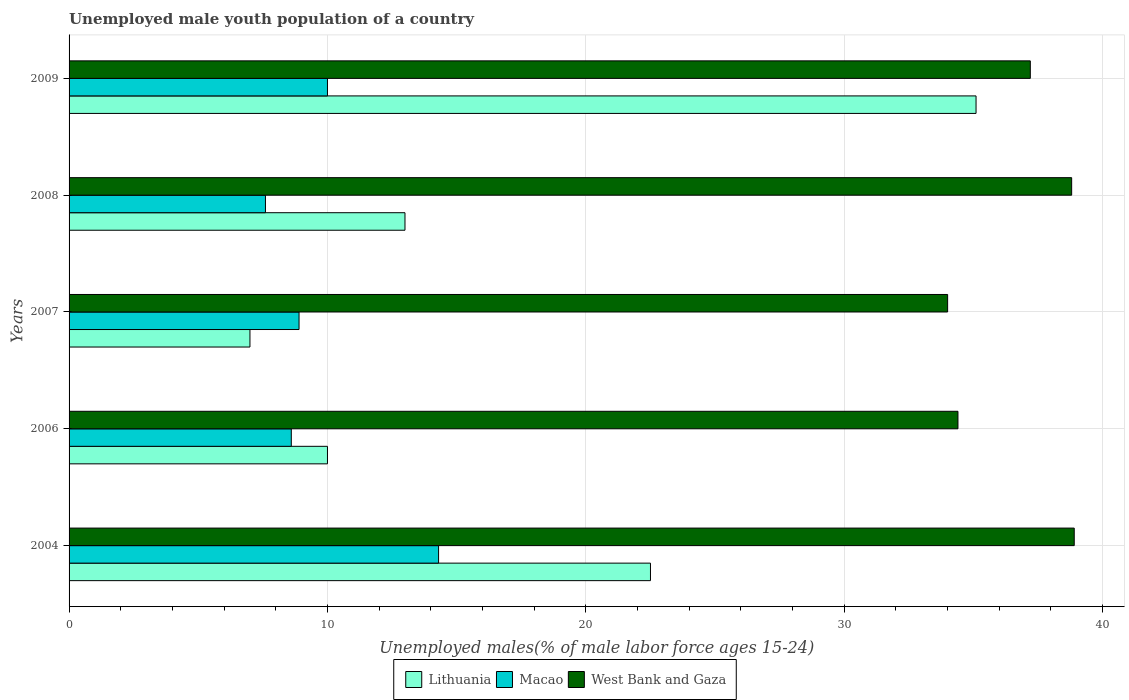What is the percentage of unemployed male youth population in Lithuania in 2009?
Your response must be concise. 35.1. Across all years, what is the maximum percentage of unemployed male youth population in Macao?
Your answer should be compact. 14.3. Across all years, what is the minimum percentage of unemployed male youth population in Lithuania?
Provide a succinct answer. 7. In which year was the percentage of unemployed male youth population in Macao maximum?
Your answer should be compact. 2004. What is the total percentage of unemployed male youth population in Lithuania in the graph?
Your response must be concise. 87.6. What is the difference between the percentage of unemployed male youth population in Macao in 2006 and that in 2008?
Your answer should be compact. 1. What is the difference between the percentage of unemployed male youth population in West Bank and Gaza in 2004 and the percentage of unemployed male youth population in Lithuania in 2006?
Your response must be concise. 28.9. What is the average percentage of unemployed male youth population in Macao per year?
Offer a very short reply. 9.88. In the year 2009, what is the difference between the percentage of unemployed male youth population in Lithuania and percentage of unemployed male youth population in West Bank and Gaza?
Offer a very short reply. -2.1. In how many years, is the percentage of unemployed male youth population in Macao greater than 26 %?
Your response must be concise. 0. What is the ratio of the percentage of unemployed male youth population in Macao in 2007 to that in 2009?
Your answer should be very brief. 0.89. Is the difference between the percentage of unemployed male youth population in Lithuania in 2006 and 2007 greater than the difference between the percentage of unemployed male youth population in West Bank and Gaza in 2006 and 2007?
Keep it short and to the point. Yes. What is the difference between the highest and the second highest percentage of unemployed male youth population in Macao?
Give a very brief answer. 4.3. What is the difference between the highest and the lowest percentage of unemployed male youth population in Lithuania?
Offer a very short reply. 28.1. What does the 2nd bar from the top in 2009 represents?
Your answer should be compact. Macao. What does the 3rd bar from the bottom in 2007 represents?
Offer a terse response. West Bank and Gaza. Is it the case that in every year, the sum of the percentage of unemployed male youth population in Macao and percentage of unemployed male youth population in West Bank and Gaza is greater than the percentage of unemployed male youth population in Lithuania?
Your answer should be very brief. Yes. What is the difference between two consecutive major ticks on the X-axis?
Give a very brief answer. 10. Are the values on the major ticks of X-axis written in scientific E-notation?
Make the answer very short. No. Does the graph contain grids?
Offer a very short reply. Yes. Where does the legend appear in the graph?
Your answer should be very brief. Bottom center. How many legend labels are there?
Provide a short and direct response. 3. How are the legend labels stacked?
Ensure brevity in your answer.  Horizontal. What is the title of the graph?
Your answer should be compact. Unemployed male youth population of a country. What is the label or title of the X-axis?
Provide a short and direct response. Unemployed males(% of male labor force ages 15-24). What is the label or title of the Y-axis?
Provide a short and direct response. Years. What is the Unemployed males(% of male labor force ages 15-24) of Lithuania in 2004?
Your answer should be compact. 22.5. What is the Unemployed males(% of male labor force ages 15-24) in Macao in 2004?
Offer a terse response. 14.3. What is the Unemployed males(% of male labor force ages 15-24) of West Bank and Gaza in 2004?
Make the answer very short. 38.9. What is the Unemployed males(% of male labor force ages 15-24) of Macao in 2006?
Your response must be concise. 8.6. What is the Unemployed males(% of male labor force ages 15-24) of West Bank and Gaza in 2006?
Keep it short and to the point. 34.4. What is the Unemployed males(% of male labor force ages 15-24) of Lithuania in 2007?
Keep it short and to the point. 7. What is the Unemployed males(% of male labor force ages 15-24) of Macao in 2007?
Provide a succinct answer. 8.9. What is the Unemployed males(% of male labor force ages 15-24) of West Bank and Gaza in 2007?
Offer a very short reply. 34. What is the Unemployed males(% of male labor force ages 15-24) in Macao in 2008?
Provide a short and direct response. 7.6. What is the Unemployed males(% of male labor force ages 15-24) of West Bank and Gaza in 2008?
Your response must be concise. 38.8. What is the Unemployed males(% of male labor force ages 15-24) of Lithuania in 2009?
Your answer should be very brief. 35.1. What is the Unemployed males(% of male labor force ages 15-24) in West Bank and Gaza in 2009?
Give a very brief answer. 37.2. Across all years, what is the maximum Unemployed males(% of male labor force ages 15-24) of Lithuania?
Provide a succinct answer. 35.1. Across all years, what is the maximum Unemployed males(% of male labor force ages 15-24) of Macao?
Your answer should be very brief. 14.3. Across all years, what is the maximum Unemployed males(% of male labor force ages 15-24) of West Bank and Gaza?
Provide a succinct answer. 38.9. Across all years, what is the minimum Unemployed males(% of male labor force ages 15-24) of Lithuania?
Keep it short and to the point. 7. Across all years, what is the minimum Unemployed males(% of male labor force ages 15-24) in Macao?
Provide a short and direct response. 7.6. What is the total Unemployed males(% of male labor force ages 15-24) in Lithuania in the graph?
Your answer should be very brief. 87.6. What is the total Unemployed males(% of male labor force ages 15-24) in Macao in the graph?
Your answer should be compact. 49.4. What is the total Unemployed males(% of male labor force ages 15-24) in West Bank and Gaza in the graph?
Your response must be concise. 183.3. What is the difference between the Unemployed males(% of male labor force ages 15-24) of West Bank and Gaza in 2004 and that in 2007?
Give a very brief answer. 4.9. What is the difference between the Unemployed males(% of male labor force ages 15-24) of Lithuania in 2004 and that in 2008?
Make the answer very short. 9.5. What is the difference between the Unemployed males(% of male labor force ages 15-24) of West Bank and Gaza in 2004 and that in 2008?
Give a very brief answer. 0.1. What is the difference between the Unemployed males(% of male labor force ages 15-24) in Macao in 2006 and that in 2007?
Offer a terse response. -0.3. What is the difference between the Unemployed males(% of male labor force ages 15-24) in West Bank and Gaza in 2006 and that in 2007?
Provide a short and direct response. 0.4. What is the difference between the Unemployed males(% of male labor force ages 15-24) in Lithuania in 2006 and that in 2008?
Give a very brief answer. -3. What is the difference between the Unemployed males(% of male labor force ages 15-24) of West Bank and Gaza in 2006 and that in 2008?
Make the answer very short. -4.4. What is the difference between the Unemployed males(% of male labor force ages 15-24) in Lithuania in 2006 and that in 2009?
Ensure brevity in your answer.  -25.1. What is the difference between the Unemployed males(% of male labor force ages 15-24) in Lithuania in 2007 and that in 2008?
Provide a succinct answer. -6. What is the difference between the Unemployed males(% of male labor force ages 15-24) of West Bank and Gaza in 2007 and that in 2008?
Keep it short and to the point. -4.8. What is the difference between the Unemployed males(% of male labor force ages 15-24) of Lithuania in 2007 and that in 2009?
Offer a terse response. -28.1. What is the difference between the Unemployed males(% of male labor force ages 15-24) of Lithuania in 2008 and that in 2009?
Provide a succinct answer. -22.1. What is the difference between the Unemployed males(% of male labor force ages 15-24) of Lithuania in 2004 and the Unemployed males(% of male labor force ages 15-24) of Macao in 2006?
Give a very brief answer. 13.9. What is the difference between the Unemployed males(% of male labor force ages 15-24) of Macao in 2004 and the Unemployed males(% of male labor force ages 15-24) of West Bank and Gaza in 2006?
Your response must be concise. -20.1. What is the difference between the Unemployed males(% of male labor force ages 15-24) of Lithuania in 2004 and the Unemployed males(% of male labor force ages 15-24) of Macao in 2007?
Provide a succinct answer. 13.6. What is the difference between the Unemployed males(% of male labor force ages 15-24) in Macao in 2004 and the Unemployed males(% of male labor force ages 15-24) in West Bank and Gaza in 2007?
Offer a very short reply. -19.7. What is the difference between the Unemployed males(% of male labor force ages 15-24) in Lithuania in 2004 and the Unemployed males(% of male labor force ages 15-24) in West Bank and Gaza in 2008?
Your response must be concise. -16.3. What is the difference between the Unemployed males(% of male labor force ages 15-24) of Macao in 2004 and the Unemployed males(% of male labor force ages 15-24) of West Bank and Gaza in 2008?
Provide a short and direct response. -24.5. What is the difference between the Unemployed males(% of male labor force ages 15-24) of Lithuania in 2004 and the Unemployed males(% of male labor force ages 15-24) of West Bank and Gaza in 2009?
Keep it short and to the point. -14.7. What is the difference between the Unemployed males(% of male labor force ages 15-24) of Macao in 2004 and the Unemployed males(% of male labor force ages 15-24) of West Bank and Gaza in 2009?
Provide a short and direct response. -22.9. What is the difference between the Unemployed males(% of male labor force ages 15-24) in Lithuania in 2006 and the Unemployed males(% of male labor force ages 15-24) in Macao in 2007?
Ensure brevity in your answer.  1.1. What is the difference between the Unemployed males(% of male labor force ages 15-24) in Lithuania in 2006 and the Unemployed males(% of male labor force ages 15-24) in West Bank and Gaza in 2007?
Offer a terse response. -24. What is the difference between the Unemployed males(% of male labor force ages 15-24) of Macao in 2006 and the Unemployed males(% of male labor force ages 15-24) of West Bank and Gaza in 2007?
Offer a very short reply. -25.4. What is the difference between the Unemployed males(% of male labor force ages 15-24) in Lithuania in 2006 and the Unemployed males(% of male labor force ages 15-24) in Macao in 2008?
Make the answer very short. 2.4. What is the difference between the Unemployed males(% of male labor force ages 15-24) in Lithuania in 2006 and the Unemployed males(% of male labor force ages 15-24) in West Bank and Gaza in 2008?
Give a very brief answer. -28.8. What is the difference between the Unemployed males(% of male labor force ages 15-24) in Macao in 2006 and the Unemployed males(% of male labor force ages 15-24) in West Bank and Gaza in 2008?
Make the answer very short. -30.2. What is the difference between the Unemployed males(% of male labor force ages 15-24) of Lithuania in 2006 and the Unemployed males(% of male labor force ages 15-24) of Macao in 2009?
Your response must be concise. 0. What is the difference between the Unemployed males(% of male labor force ages 15-24) in Lithuania in 2006 and the Unemployed males(% of male labor force ages 15-24) in West Bank and Gaza in 2009?
Provide a short and direct response. -27.2. What is the difference between the Unemployed males(% of male labor force ages 15-24) of Macao in 2006 and the Unemployed males(% of male labor force ages 15-24) of West Bank and Gaza in 2009?
Provide a succinct answer. -28.6. What is the difference between the Unemployed males(% of male labor force ages 15-24) in Lithuania in 2007 and the Unemployed males(% of male labor force ages 15-24) in Macao in 2008?
Your answer should be compact. -0.6. What is the difference between the Unemployed males(% of male labor force ages 15-24) of Lithuania in 2007 and the Unemployed males(% of male labor force ages 15-24) of West Bank and Gaza in 2008?
Offer a very short reply. -31.8. What is the difference between the Unemployed males(% of male labor force ages 15-24) of Macao in 2007 and the Unemployed males(% of male labor force ages 15-24) of West Bank and Gaza in 2008?
Your answer should be compact. -29.9. What is the difference between the Unemployed males(% of male labor force ages 15-24) in Lithuania in 2007 and the Unemployed males(% of male labor force ages 15-24) in West Bank and Gaza in 2009?
Make the answer very short. -30.2. What is the difference between the Unemployed males(% of male labor force ages 15-24) in Macao in 2007 and the Unemployed males(% of male labor force ages 15-24) in West Bank and Gaza in 2009?
Your response must be concise. -28.3. What is the difference between the Unemployed males(% of male labor force ages 15-24) in Lithuania in 2008 and the Unemployed males(% of male labor force ages 15-24) in West Bank and Gaza in 2009?
Give a very brief answer. -24.2. What is the difference between the Unemployed males(% of male labor force ages 15-24) of Macao in 2008 and the Unemployed males(% of male labor force ages 15-24) of West Bank and Gaza in 2009?
Ensure brevity in your answer.  -29.6. What is the average Unemployed males(% of male labor force ages 15-24) in Lithuania per year?
Provide a succinct answer. 17.52. What is the average Unemployed males(% of male labor force ages 15-24) of Macao per year?
Your answer should be compact. 9.88. What is the average Unemployed males(% of male labor force ages 15-24) of West Bank and Gaza per year?
Ensure brevity in your answer.  36.66. In the year 2004, what is the difference between the Unemployed males(% of male labor force ages 15-24) of Lithuania and Unemployed males(% of male labor force ages 15-24) of West Bank and Gaza?
Your response must be concise. -16.4. In the year 2004, what is the difference between the Unemployed males(% of male labor force ages 15-24) in Macao and Unemployed males(% of male labor force ages 15-24) in West Bank and Gaza?
Make the answer very short. -24.6. In the year 2006, what is the difference between the Unemployed males(% of male labor force ages 15-24) of Lithuania and Unemployed males(% of male labor force ages 15-24) of West Bank and Gaza?
Provide a short and direct response. -24.4. In the year 2006, what is the difference between the Unemployed males(% of male labor force ages 15-24) in Macao and Unemployed males(% of male labor force ages 15-24) in West Bank and Gaza?
Provide a short and direct response. -25.8. In the year 2007, what is the difference between the Unemployed males(% of male labor force ages 15-24) in Lithuania and Unemployed males(% of male labor force ages 15-24) in Macao?
Your answer should be very brief. -1.9. In the year 2007, what is the difference between the Unemployed males(% of male labor force ages 15-24) of Lithuania and Unemployed males(% of male labor force ages 15-24) of West Bank and Gaza?
Keep it short and to the point. -27. In the year 2007, what is the difference between the Unemployed males(% of male labor force ages 15-24) of Macao and Unemployed males(% of male labor force ages 15-24) of West Bank and Gaza?
Your response must be concise. -25.1. In the year 2008, what is the difference between the Unemployed males(% of male labor force ages 15-24) in Lithuania and Unemployed males(% of male labor force ages 15-24) in Macao?
Provide a succinct answer. 5.4. In the year 2008, what is the difference between the Unemployed males(% of male labor force ages 15-24) of Lithuania and Unemployed males(% of male labor force ages 15-24) of West Bank and Gaza?
Offer a very short reply. -25.8. In the year 2008, what is the difference between the Unemployed males(% of male labor force ages 15-24) in Macao and Unemployed males(% of male labor force ages 15-24) in West Bank and Gaza?
Offer a very short reply. -31.2. In the year 2009, what is the difference between the Unemployed males(% of male labor force ages 15-24) of Lithuania and Unemployed males(% of male labor force ages 15-24) of Macao?
Offer a very short reply. 25.1. In the year 2009, what is the difference between the Unemployed males(% of male labor force ages 15-24) in Macao and Unemployed males(% of male labor force ages 15-24) in West Bank and Gaza?
Keep it short and to the point. -27.2. What is the ratio of the Unemployed males(% of male labor force ages 15-24) of Lithuania in 2004 to that in 2006?
Provide a succinct answer. 2.25. What is the ratio of the Unemployed males(% of male labor force ages 15-24) of Macao in 2004 to that in 2006?
Provide a succinct answer. 1.66. What is the ratio of the Unemployed males(% of male labor force ages 15-24) in West Bank and Gaza in 2004 to that in 2006?
Give a very brief answer. 1.13. What is the ratio of the Unemployed males(% of male labor force ages 15-24) of Lithuania in 2004 to that in 2007?
Give a very brief answer. 3.21. What is the ratio of the Unemployed males(% of male labor force ages 15-24) of Macao in 2004 to that in 2007?
Provide a succinct answer. 1.61. What is the ratio of the Unemployed males(% of male labor force ages 15-24) in West Bank and Gaza in 2004 to that in 2007?
Your response must be concise. 1.14. What is the ratio of the Unemployed males(% of male labor force ages 15-24) of Lithuania in 2004 to that in 2008?
Provide a short and direct response. 1.73. What is the ratio of the Unemployed males(% of male labor force ages 15-24) in Macao in 2004 to that in 2008?
Your answer should be compact. 1.88. What is the ratio of the Unemployed males(% of male labor force ages 15-24) in West Bank and Gaza in 2004 to that in 2008?
Give a very brief answer. 1. What is the ratio of the Unemployed males(% of male labor force ages 15-24) in Lithuania in 2004 to that in 2009?
Ensure brevity in your answer.  0.64. What is the ratio of the Unemployed males(% of male labor force ages 15-24) in Macao in 2004 to that in 2009?
Give a very brief answer. 1.43. What is the ratio of the Unemployed males(% of male labor force ages 15-24) in West Bank and Gaza in 2004 to that in 2009?
Ensure brevity in your answer.  1.05. What is the ratio of the Unemployed males(% of male labor force ages 15-24) in Lithuania in 2006 to that in 2007?
Offer a very short reply. 1.43. What is the ratio of the Unemployed males(% of male labor force ages 15-24) of Macao in 2006 to that in 2007?
Make the answer very short. 0.97. What is the ratio of the Unemployed males(% of male labor force ages 15-24) in West Bank and Gaza in 2006 to that in 2007?
Keep it short and to the point. 1.01. What is the ratio of the Unemployed males(% of male labor force ages 15-24) of Lithuania in 2006 to that in 2008?
Make the answer very short. 0.77. What is the ratio of the Unemployed males(% of male labor force ages 15-24) in Macao in 2006 to that in 2008?
Your answer should be compact. 1.13. What is the ratio of the Unemployed males(% of male labor force ages 15-24) in West Bank and Gaza in 2006 to that in 2008?
Provide a short and direct response. 0.89. What is the ratio of the Unemployed males(% of male labor force ages 15-24) in Lithuania in 2006 to that in 2009?
Keep it short and to the point. 0.28. What is the ratio of the Unemployed males(% of male labor force ages 15-24) in Macao in 2006 to that in 2009?
Make the answer very short. 0.86. What is the ratio of the Unemployed males(% of male labor force ages 15-24) in West Bank and Gaza in 2006 to that in 2009?
Ensure brevity in your answer.  0.92. What is the ratio of the Unemployed males(% of male labor force ages 15-24) in Lithuania in 2007 to that in 2008?
Your answer should be very brief. 0.54. What is the ratio of the Unemployed males(% of male labor force ages 15-24) in Macao in 2007 to that in 2008?
Offer a very short reply. 1.17. What is the ratio of the Unemployed males(% of male labor force ages 15-24) of West Bank and Gaza in 2007 to that in 2008?
Your answer should be very brief. 0.88. What is the ratio of the Unemployed males(% of male labor force ages 15-24) of Lithuania in 2007 to that in 2009?
Your answer should be compact. 0.2. What is the ratio of the Unemployed males(% of male labor force ages 15-24) of Macao in 2007 to that in 2009?
Ensure brevity in your answer.  0.89. What is the ratio of the Unemployed males(% of male labor force ages 15-24) in West Bank and Gaza in 2007 to that in 2009?
Keep it short and to the point. 0.91. What is the ratio of the Unemployed males(% of male labor force ages 15-24) in Lithuania in 2008 to that in 2009?
Provide a short and direct response. 0.37. What is the ratio of the Unemployed males(% of male labor force ages 15-24) in Macao in 2008 to that in 2009?
Your answer should be compact. 0.76. What is the ratio of the Unemployed males(% of male labor force ages 15-24) in West Bank and Gaza in 2008 to that in 2009?
Make the answer very short. 1.04. What is the difference between the highest and the second highest Unemployed males(% of male labor force ages 15-24) in Lithuania?
Offer a terse response. 12.6. What is the difference between the highest and the second highest Unemployed males(% of male labor force ages 15-24) in West Bank and Gaza?
Provide a succinct answer. 0.1. What is the difference between the highest and the lowest Unemployed males(% of male labor force ages 15-24) of Lithuania?
Provide a succinct answer. 28.1. 